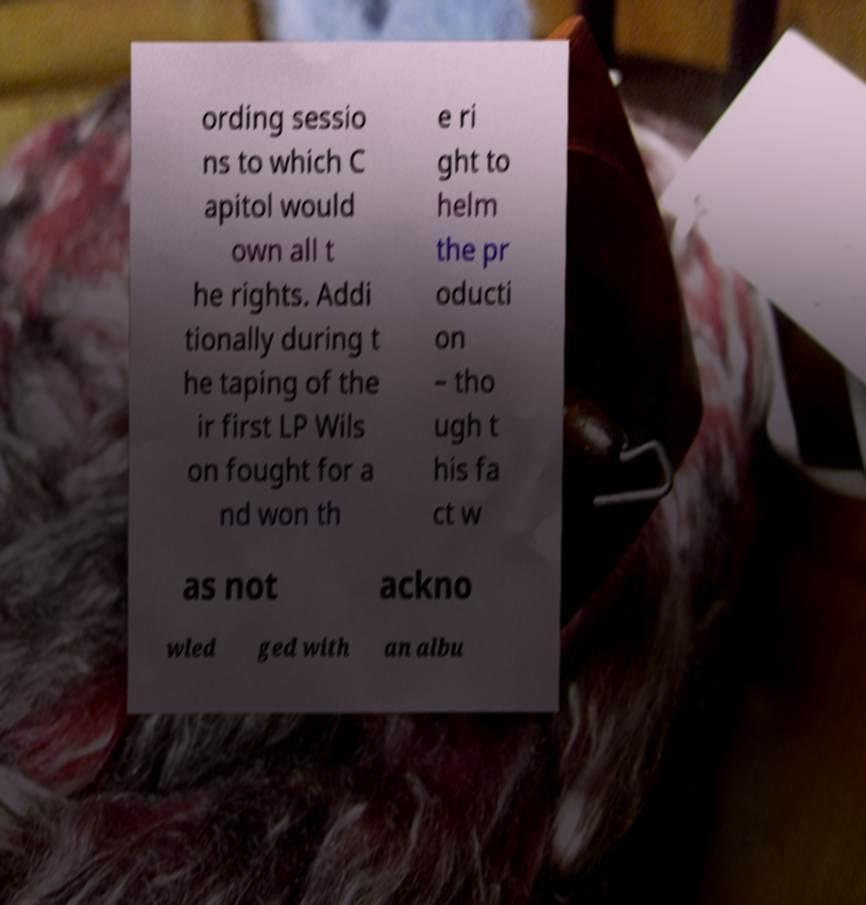I need the written content from this picture converted into text. Can you do that? ording sessio ns to which C apitol would own all t he rights. Addi tionally during t he taping of the ir first LP Wils on fought for a nd won th e ri ght to helm the pr oducti on – tho ugh t his fa ct w as not ackno wled ged with an albu 